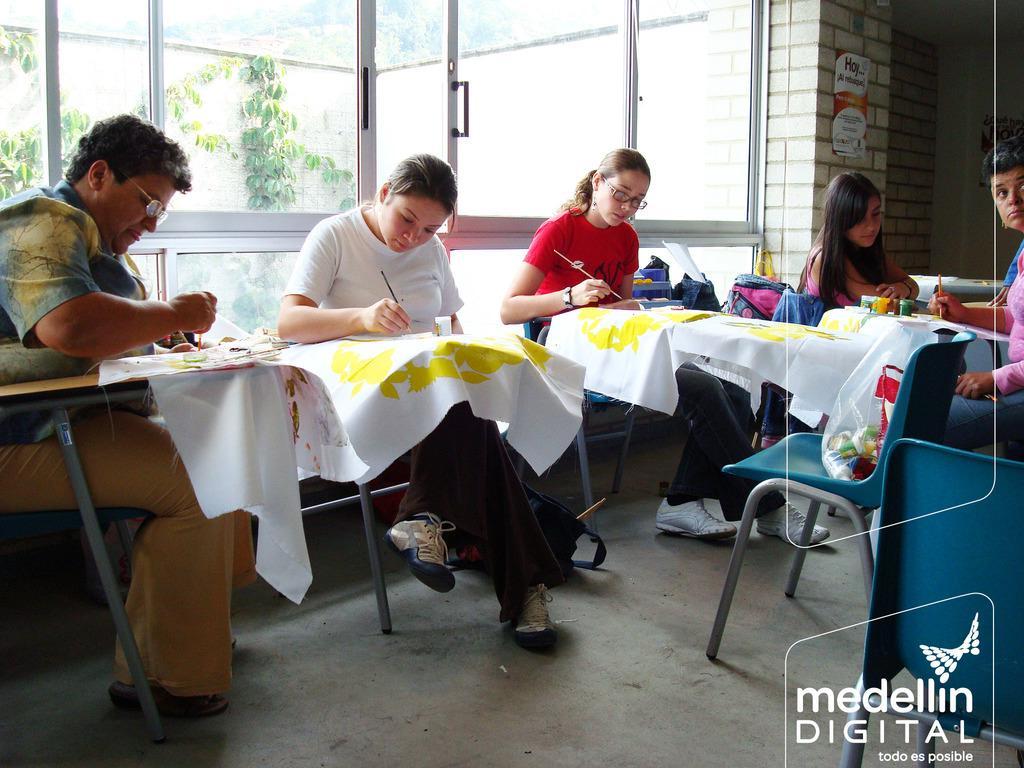How would you summarize this image in a sentence or two? This group of people are sitting on chairs and holding paint brushes. In-front of them there are tables, on this table there is a cloth and this three persons are painting on this cloth. On this table there are paint bottles. On this chair is a plastic cover. Far there are bags. A poster on wall. From this window we can able to see trees. 